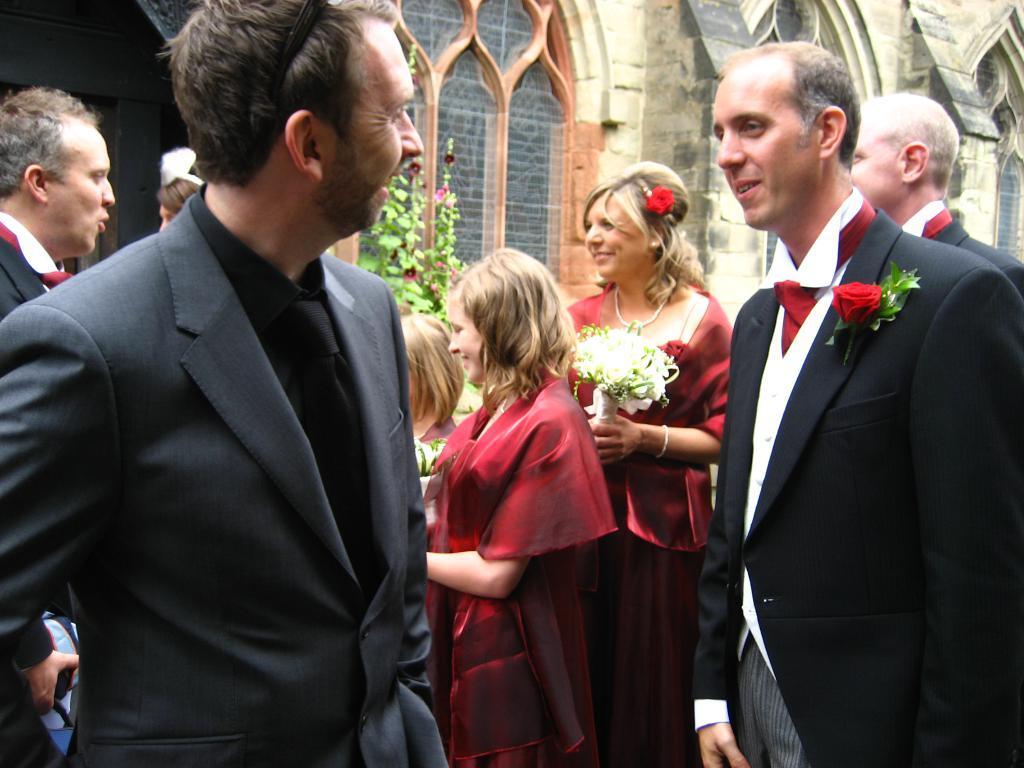Describe this image in one or two sentences. In this picture I can see a group of people are standing among them this woman is holding a flower bouquet in the hands. These men are wearing black color suits. In the background I can see a building and plants. 